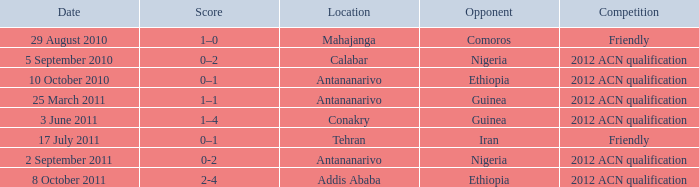What is the score at the Addis Ababa location? 2-4. 